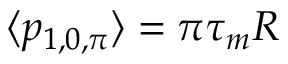<formula> <loc_0><loc_0><loc_500><loc_500>\langle p _ { 1 , 0 , \pi } \rangle = \pi \tau _ { m } R</formula> 